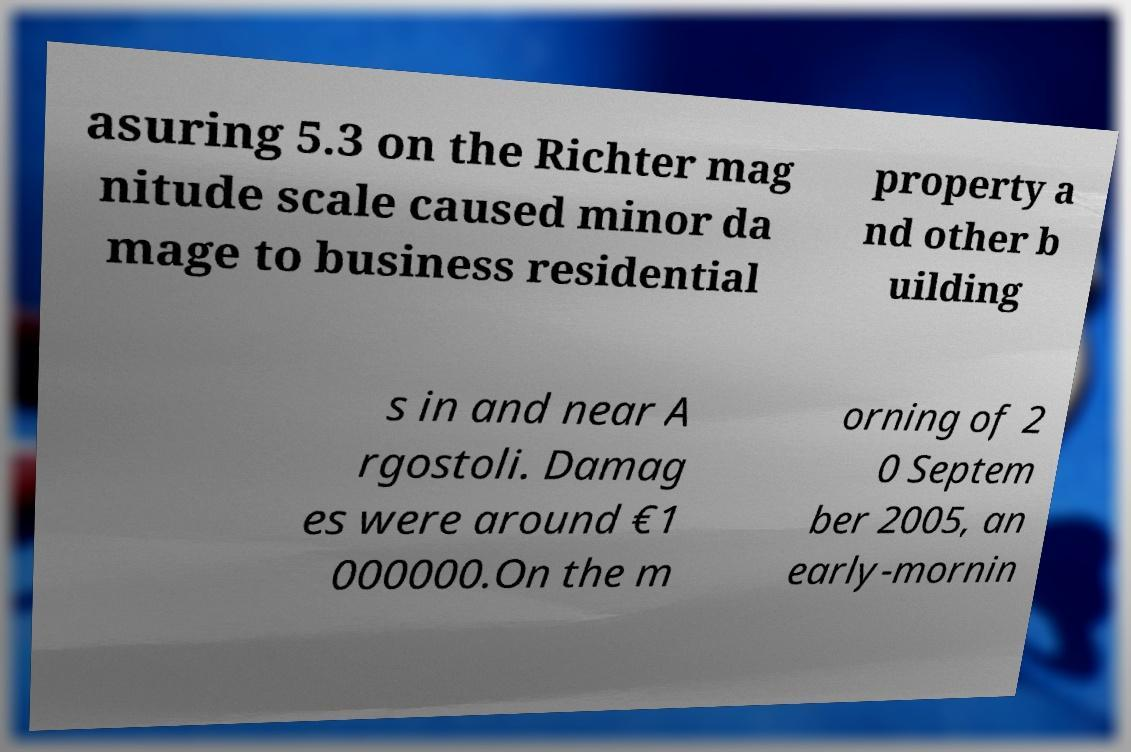I need the written content from this picture converted into text. Can you do that? asuring 5.3 on the Richter mag nitude scale caused minor da mage to business residential property a nd other b uilding s in and near A rgostoli. Damag es were around €1 000000.On the m orning of 2 0 Septem ber 2005, an early-mornin 